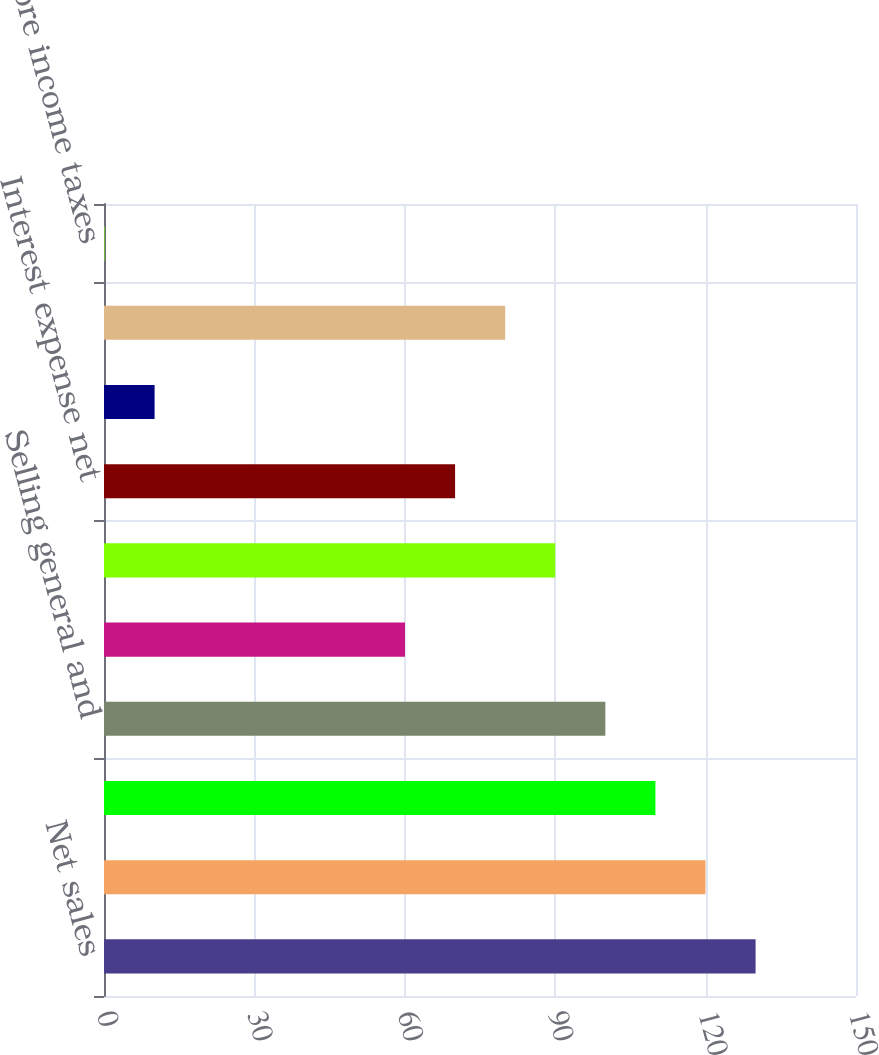Convert chart to OTSL. <chart><loc_0><loc_0><loc_500><loc_500><bar_chart><fcel>Net sales<fcel>Cost of products sold<fcel>Gross margin<fcel>Selling general and<fcel>Restructuring costs<fcel>Operating income<fcel>Interest expense net<fcel>Losses related to<fcel>Net nonoperating expenses<fcel>Income before income taxes<nl><fcel>129.97<fcel>119.98<fcel>109.99<fcel>100<fcel>60.04<fcel>90.01<fcel>70.03<fcel>10.09<fcel>80.02<fcel>0.1<nl></chart> 